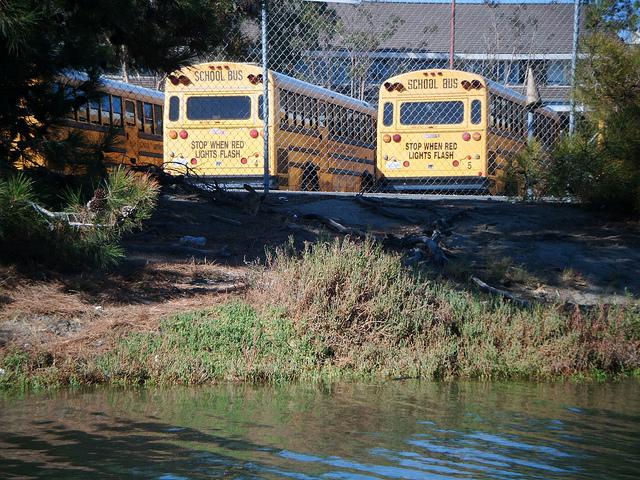What type of bugs are these?
Concise answer only. School. What is the water like?
Give a very brief answer. Still. Could this bus be in a rural area?
Quick response, please. Yes. Are there trains?
Quick response, please. No. Can you see through the fence?
Concise answer only. Yes. 